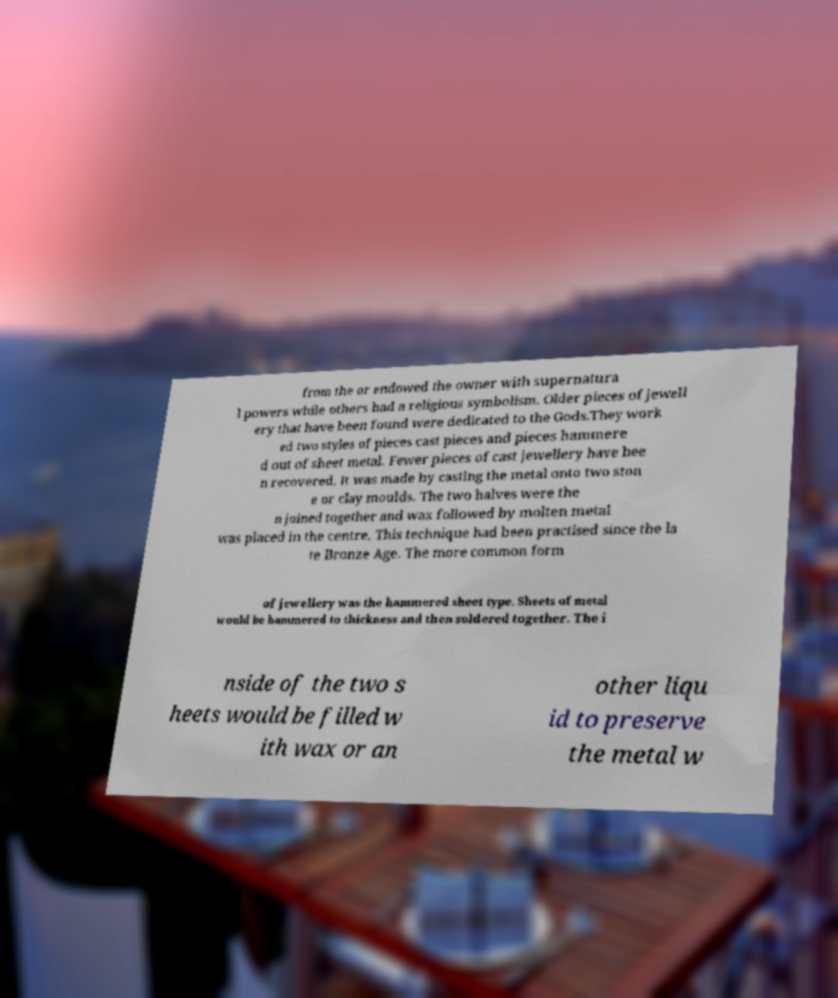Could you extract and type out the text from this image? from the or endowed the owner with supernatura l powers while others had a religious symbolism. Older pieces of jewell ery that have been found were dedicated to the Gods.They work ed two styles of pieces cast pieces and pieces hammere d out of sheet metal. Fewer pieces of cast jewellery have bee n recovered. It was made by casting the metal onto two ston e or clay moulds. The two halves were the n joined together and wax followed by molten metal was placed in the centre. This technique had been practised since the la te Bronze Age. The more common form of jewellery was the hammered sheet type. Sheets of metal would be hammered to thickness and then soldered together. The i nside of the two s heets would be filled w ith wax or an other liqu id to preserve the metal w 